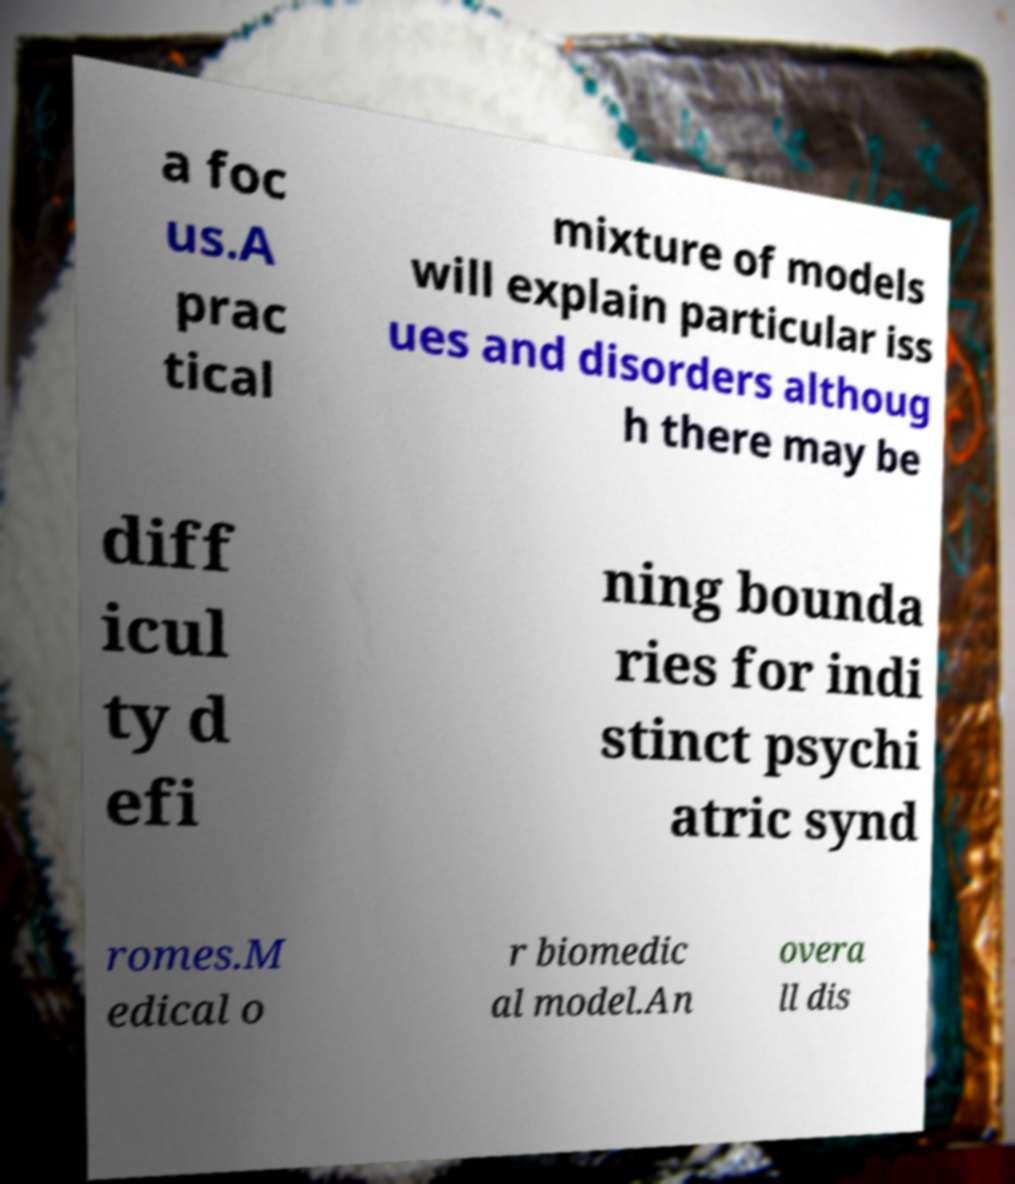For documentation purposes, I need the text within this image transcribed. Could you provide that? a foc us.A prac tical mixture of models will explain particular iss ues and disorders althoug h there may be diff icul ty d efi ning bounda ries for indi stinct psychi atric synd romes.M edical o r biomedic al model.An overa ll dis 